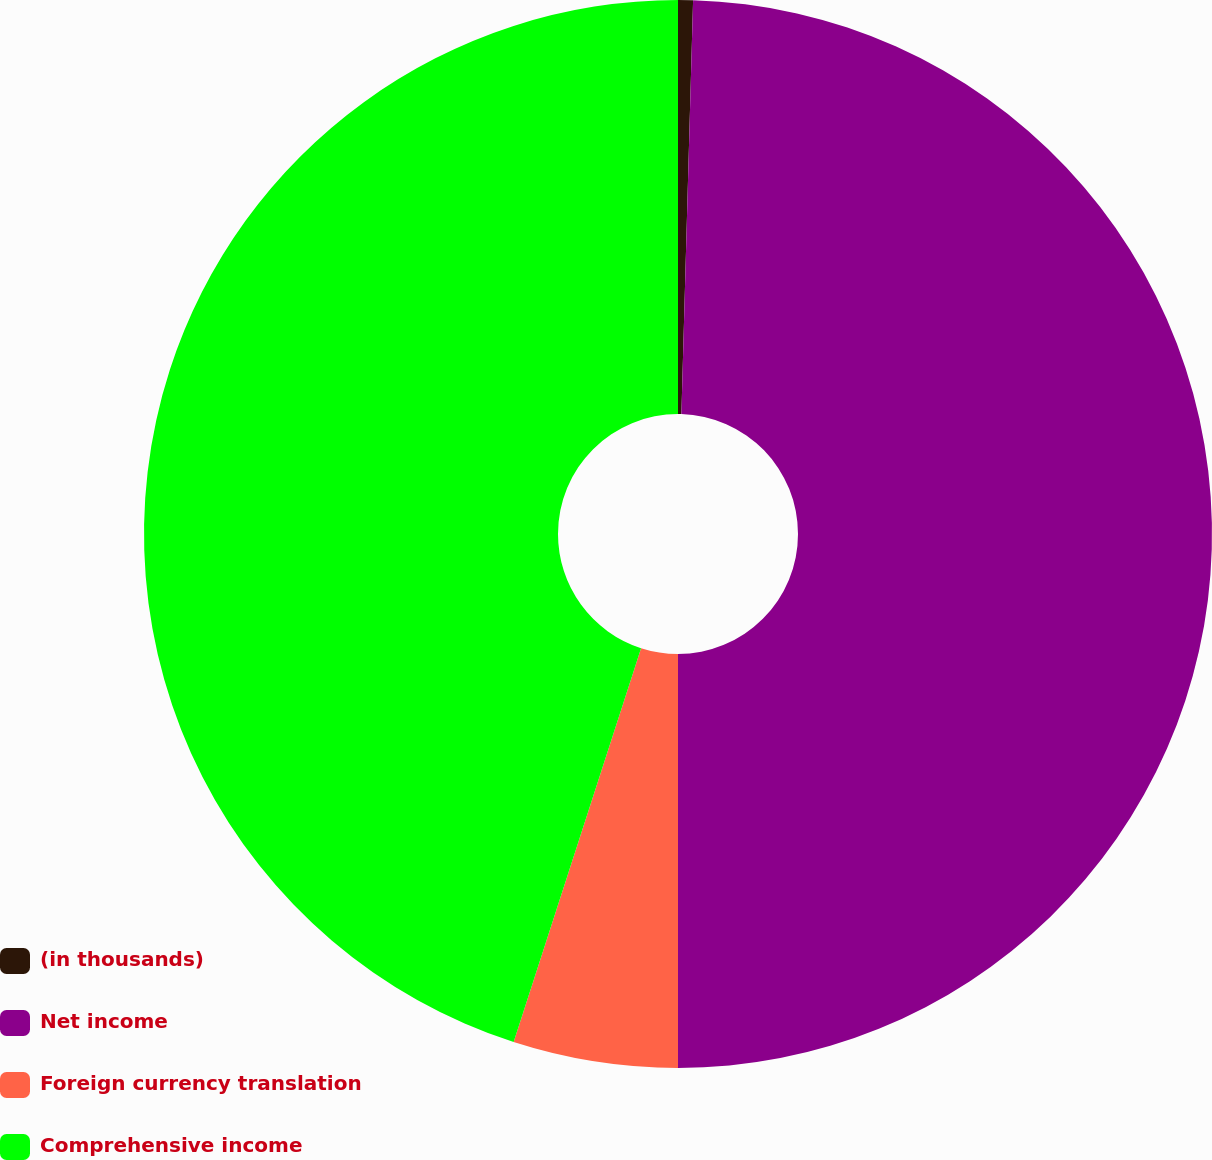Convert chart. <chart><loc_0><loc_0><loc_500><loc_500><pie_chart><fcel>(in thousands)<fcel>Net income<fcel>Foreign currency translation<fcel>Comprehensive income<nl><fcel>0.45%<fcel>49.55%<fcel>4.98%<fcel>45.02%<nl></chart> 